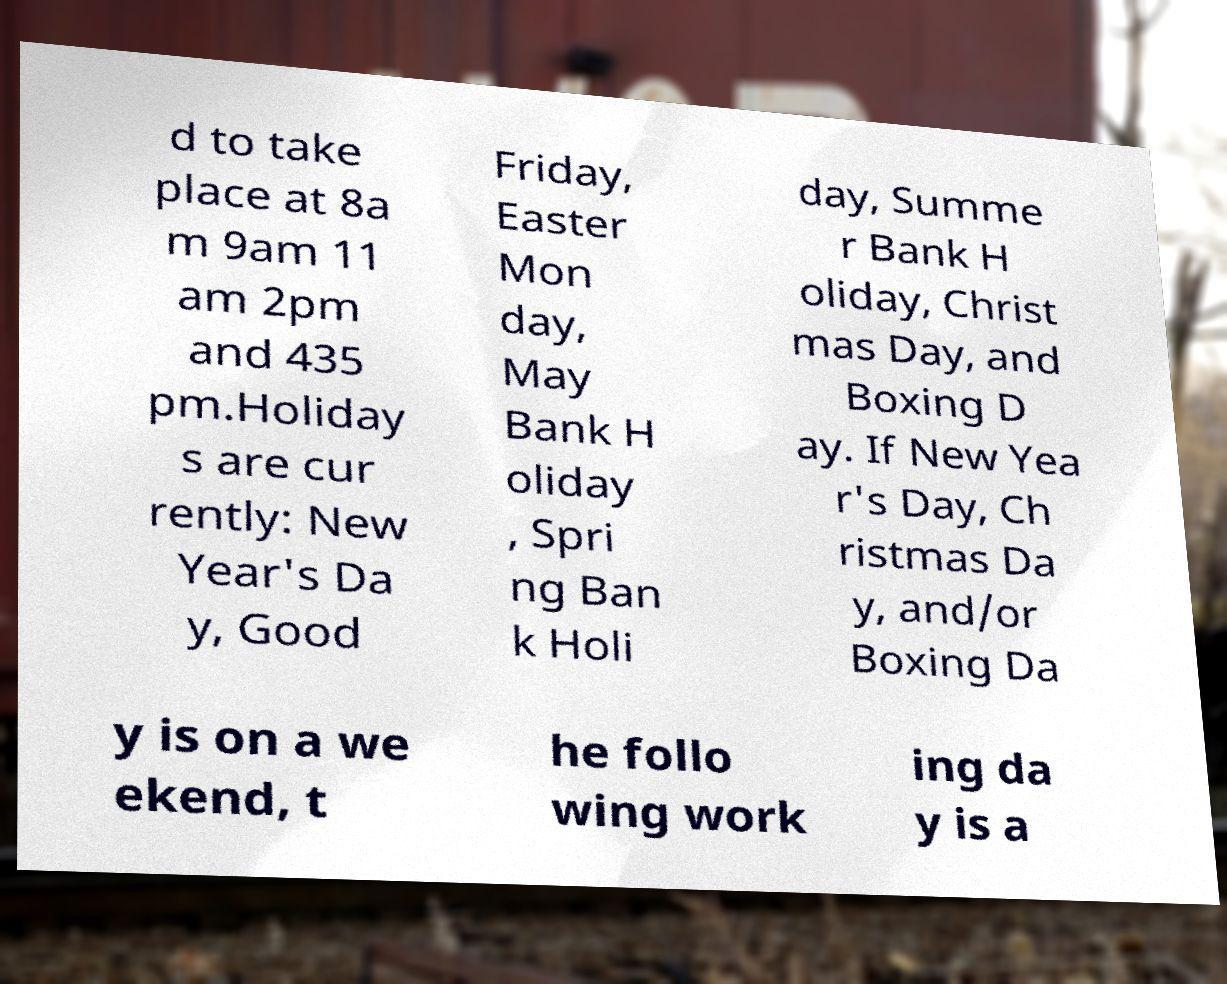Can you read and provide the text displayed in the image?This photo seems to have some interesting text. Can you extract and type it out for me? d to take place at 8a m 9am 11 am 2pm and 435 pm.Holiday s are cur rently: New Year's Da y, Good Friday, Easter Mon day, May Bank H oliday , Spri ng Ban k Holi day, Summe r Bank H oliday, Christ mas Day, and Boxing D ay. If New Yea r's Day, Ch ristmas Da y, and/or Boxing Da y is on a we ekend, t he follo wing work ing da y is a 